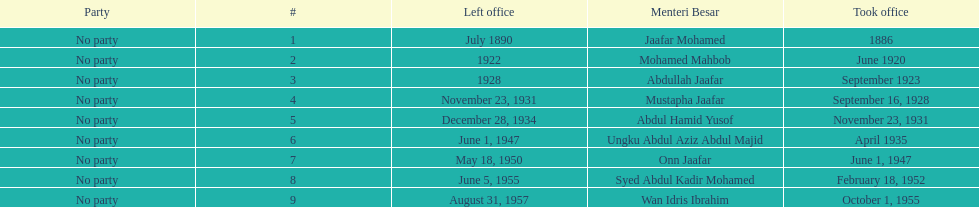Who took office after abdullah jaafar? Mustapha Jaafar. 